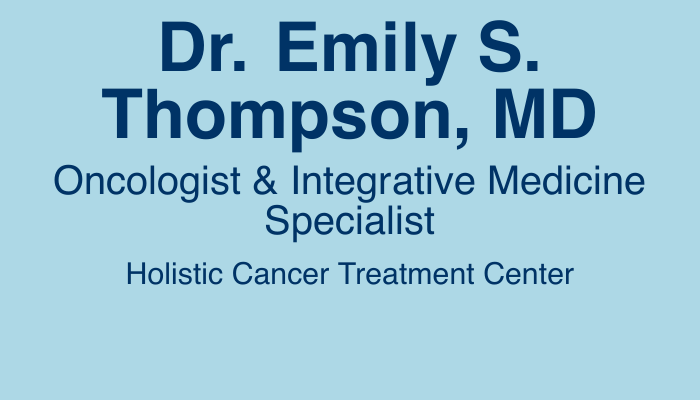What is the name of the oncologist? The name is presented at the top of the document in a prominent font.
Answer: Dr. Emily S. Thompson, MD What is the specialty of Dr. Thompson? The specialty is indicated directly below the name.
Answer: Oncologist & Integrative Medicine Specialist What is the phone number listed on the card? The phone number is provided in the contact information section.
Answer: (555) 123-4567 What is the address of the Holistic Cancer Treatment Center? The address is part of the contact details on the card.
Answer: 123 Main Street, Suite 400, Anytown, USA What type of medicine does Dr. Thompson focus on? The type of medicine is mentioned in the specialty and is characteristic of the practice.
Answer: Integrative Medicine What services are highlighted on the business card? The services are summarized at the bottom of the document, indicating the main focus areas.
Answer: Comprehensive Cancer Care • Collaborative Patient Care • Evidence-Based Integrative Medicine What type of center is mentioned on the card? The type of center is part of the holistic approach highlighted on the card.
Answer: Holistic Cancer Treatment Center What is the URL encoded in the QR code? The QR code represents a link related to the services.
Answer: https://holisticcancercenter.org 